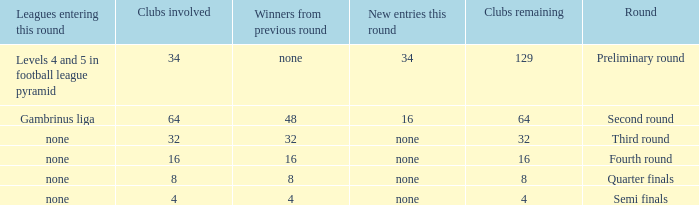Name the least clubs involved for leagues being none for semi finals 4.0. 